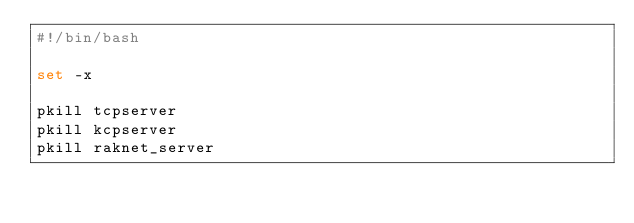<code> <loc_0><loc_0><loc_500><loc_500><_Bash_>#!/bin/bash

set -x

pkill tcpserver
pkill kcpserver
pkill raknet_server

</code> 